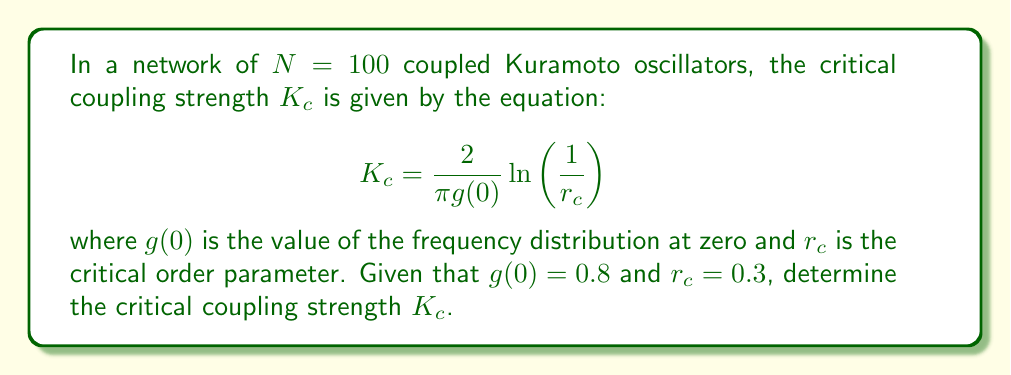Teach me how to tackle this problem. To solve this problem, we need to use the given logarithmic equation and substitute the known values. Let's break it down step-by-step:

1) We are given the equation:
   $$K_c = \frac{2}{\pi g(0)} \ln\left(\frac{1}{r_c}\right)$$

2) We know that:
   $g(0) = 0.8$
   $r_c = 0.3$

3) Let's substitute these values into the equation:
   $$K_c = \frac{2}{\pi (0.8)} \ln\left(\frac{1}{0.3}\right)$$

4) First, let's simplify the fraction outside the logarithm:
   $$K_c = \frac{2.5}{\pi} \ln\left(\frac{1}{0.3}\right)$$

5) Now, let's evaluate the logarithm:
   $\ln\left(\frac{1}{0.3}\right) = \ln(3.333...) \approx 1.2040$

6) Substituting this back into our equation:
   $$K_c = \frac{2.5}{\pi} (1.2040)$$

7) Finally, let's calculate this value:
   $$K_c \approx 0.9579$$

Thus, the critical coupling strength is approximately 0.9579.
Answer: $K_c \approx 0.9579$ 